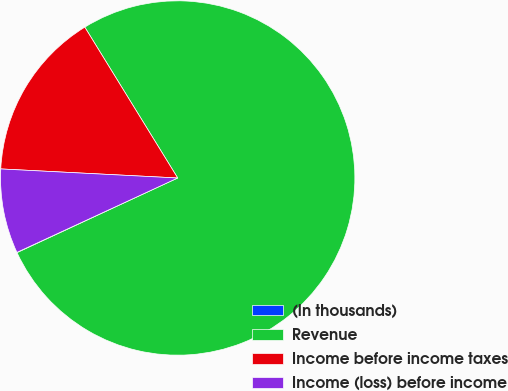Convert chart. <chart><loc_0><loc_0><loc_500><loc_500><pie_chart><fcel>(In thousands)<fcel>Revenue<fcel>Income before income taxes<fcel>Income (loss) before income<nl><fcel>0.03%<fcel>76.86%<fcel>15.4%<fcel>7.71%<nl></chart> 